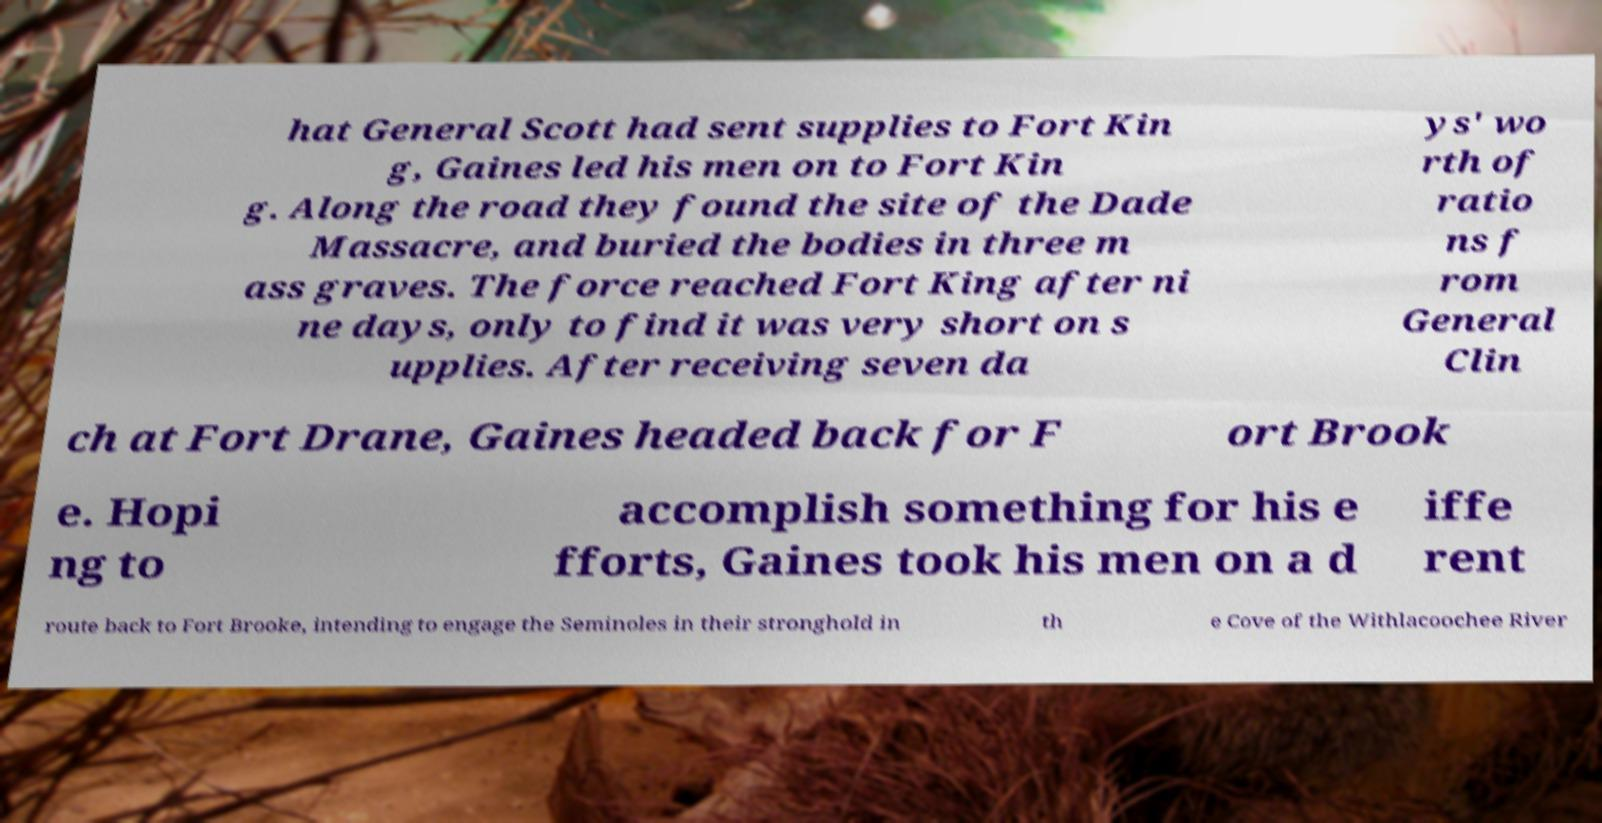Please identify and transcribe the text found in this image. hat General Scott had sent supplies to Fort Kin g, Gaines led his men on to Fort Kin g. Along the road they found the site of the Dade Massacre, and buried the bodies in three m ass graves. The force reached Fort King after ni ne days, only to find it was very short on s upplies. After receiving seven da ys' wo rth of ratio ns f rom General Clin ch at Fort Drane, Gaines headed back for F ort Brook e. Hopi ng to accomplish something for his e fforts, Gaines took his men on a d iffe rent route back to Fort Brooke, intending to engage the Seminoles in their stronghold in th e Cove of the Withlacoochee River 